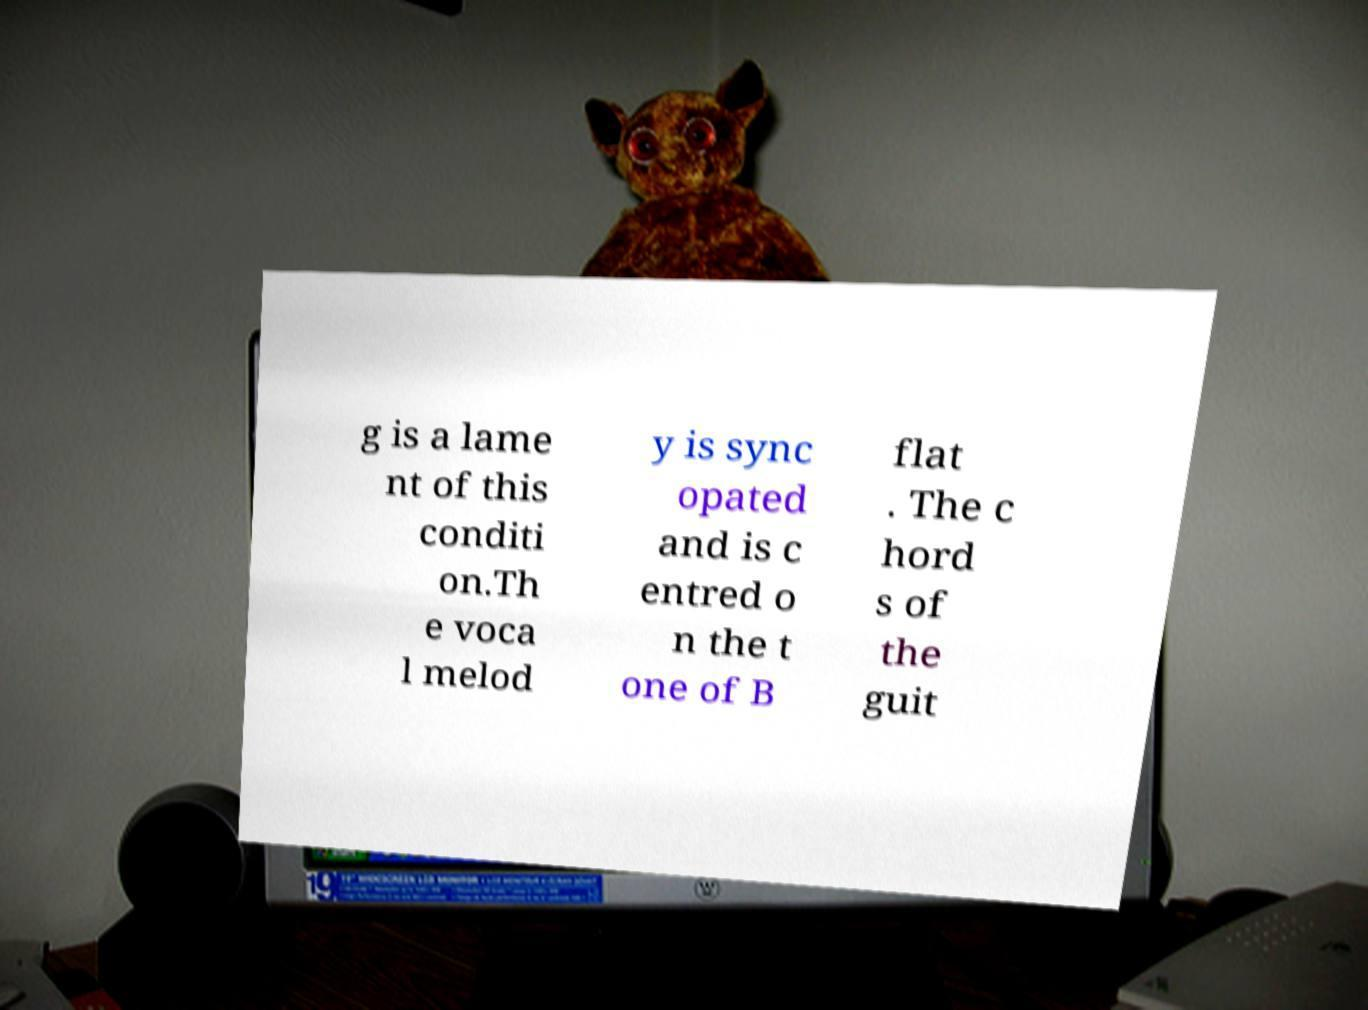Could you extract and type out the text from this image? g is a lame nt of this conditi on.Th e voca l melod y is sync opated and is c entred o n the t one of B flat . The c hord s of the guit 